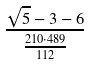<formula> <loc_0><loc_0><loc_500><loc_500>\frac { \sqrt { 5 } - 3 - 6 } { \frac { 2 1 0 \cdot 4 8 9 } { 1 1 2 } }</formula> 